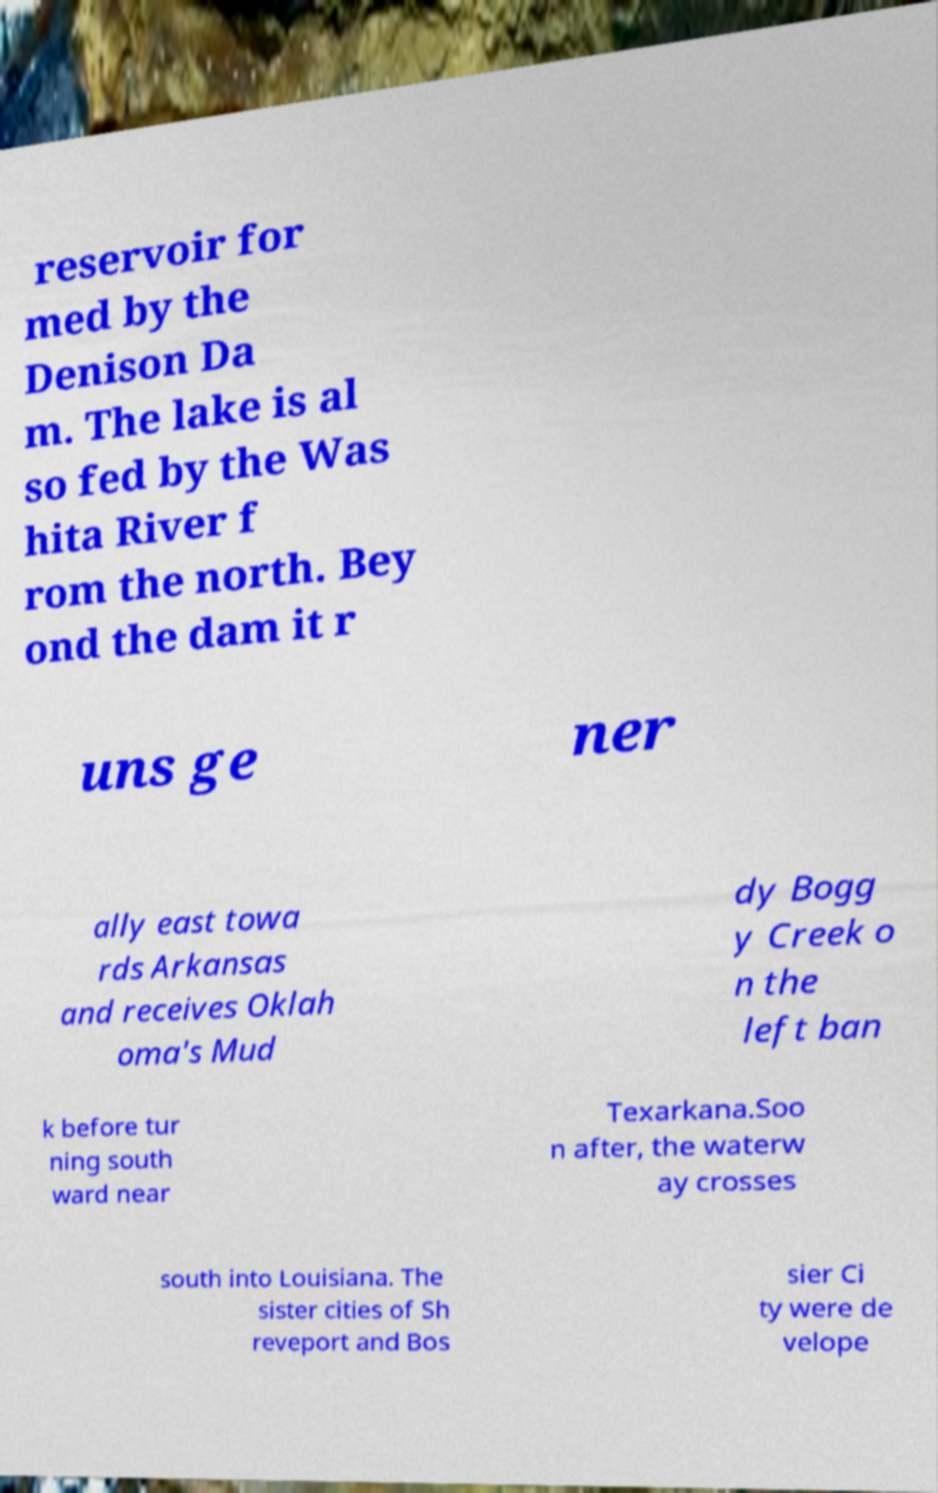Please identify and transcribe the text found in this image. reservoir for med by the Denison Da m. The lake is al so fed by the Was hita River f rom the north. Bey ond the dam it r uns ge ner ally east towa rds Arkansas and receives Oklah oma's Mud dy Bogg y Creek o n the left ban k before tur ning south ward near Texarkana.Soo n after, the waterw ay crosses south into Louisiana. The sister cities of Sh reveport and Bos sier Ci ty were de velope 